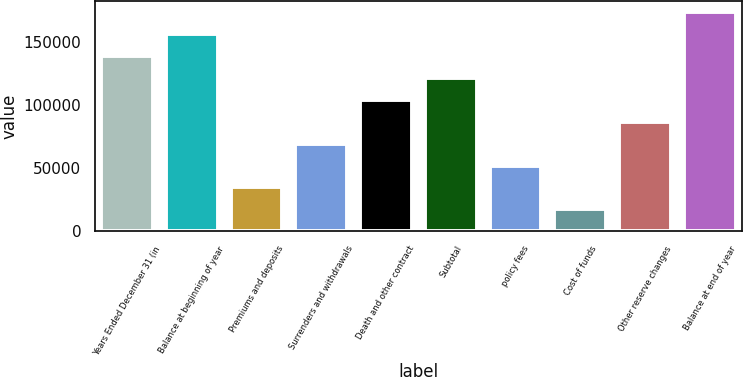Convert chart to OTSL. <chart><loc_0><loc_0><loc_500><loc_500><bar_chart><fcel>Years Ended December 31 (in<fcel>Balance at beginning of year<fcel>Premiums and deposits<fcel>Surrenders and withdrawals<fcel>Death and other contract<fcel>Subtotal<fcel>policy fees<fcel>Cost of funds<fcel>Other reserve changes<fcel>Balance at end of year<nl><fcel>138690<fcel>156025<fcel>34679.2<fcel>69349.4<fcel>104020<fcel>121355<fcel>52014.3<fcel>17344.1<fcel>86684.5<fcel>173360<nl></chart> 